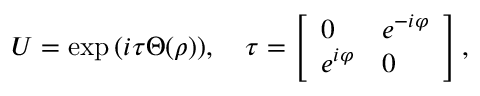<formula> <loc_0><loc_0><loc_500><loc_500>U = \exp \, ( i \tau \Theta ( \rho ) ) , \quad \tau = \left [ \begin{array} { l l } { 0 } & { { e ^ { - i \varphi } } } \\ { { e ^ { i \varphi } } } & { 0 } \end{array} \right ] ,</formula> 